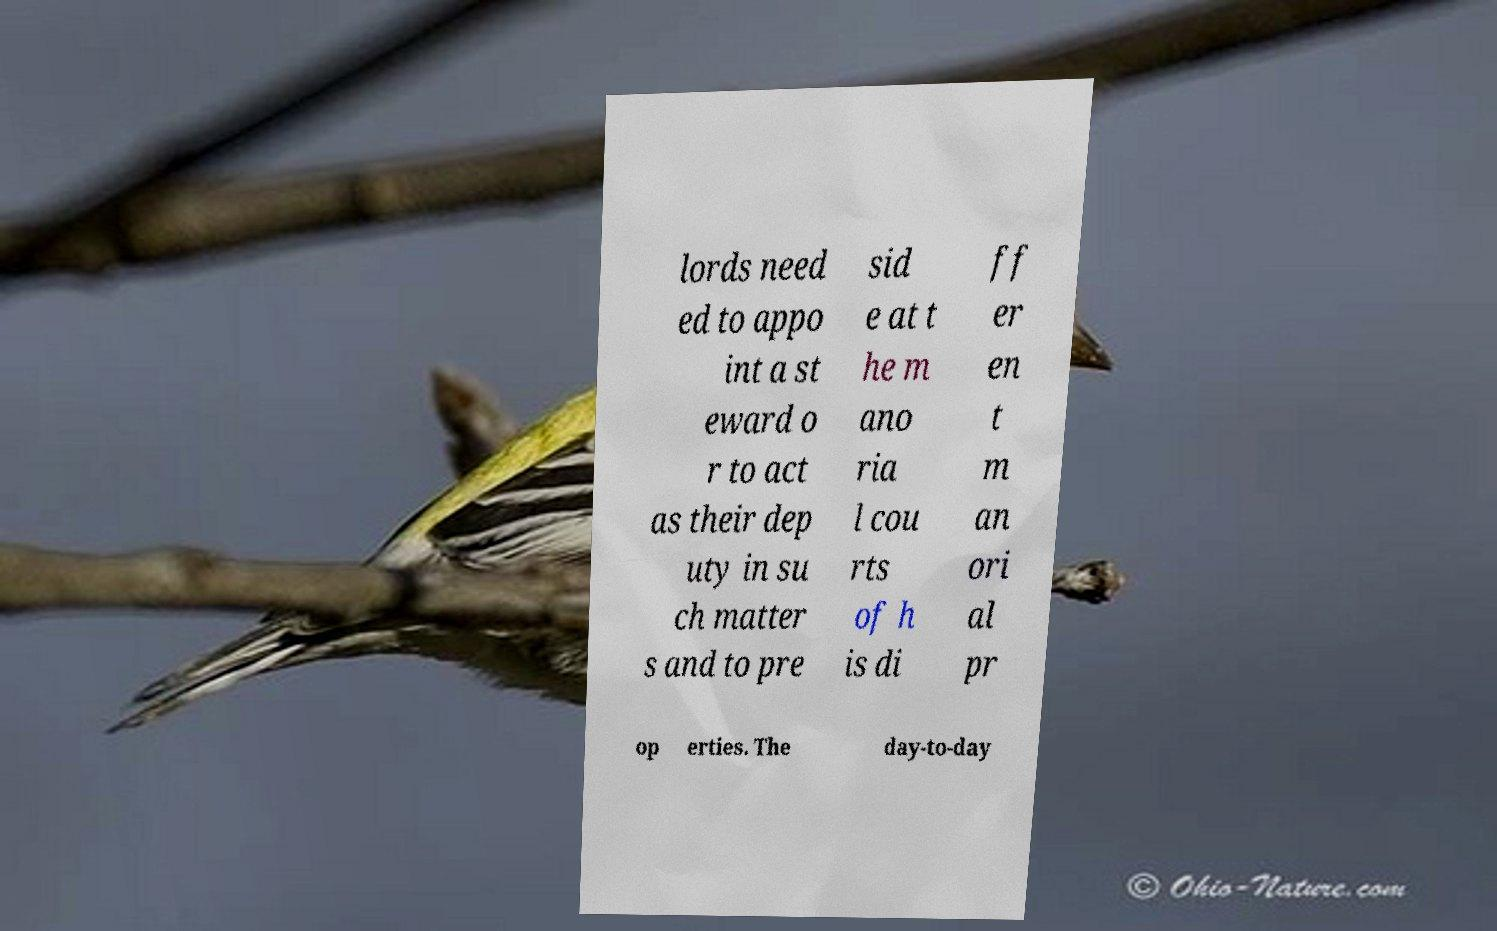For documentation purposes, I need the text within this image transcribed. Could you provide that? lords need ed to appo int a st eward o r to act as their dep uty in su ch matter s and to pre sid e at t he m ano ria l cou rts of h is di ff er en t m an ori al pr op erties. The day-to-day 